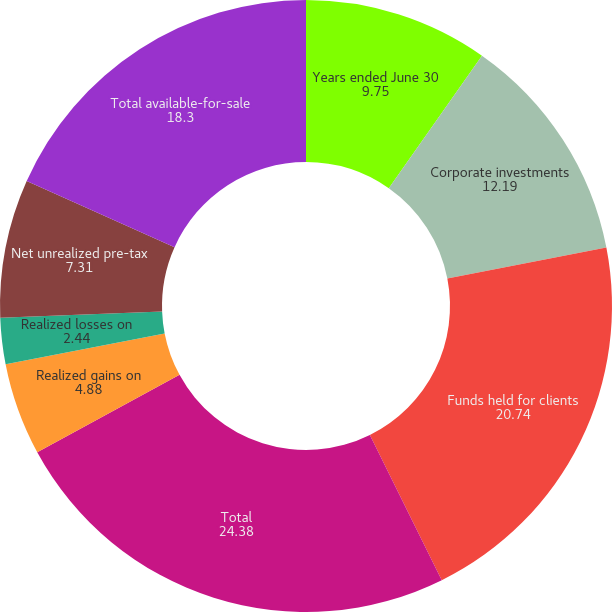Convert chart to OTSL. <chart><loc_0><loc_0><loc_500><loc_500><pie_chart><fcel>Years ended June 30<fcel>Corporate investments<fcel>Funds held for clients<fcel>Total<fcel>Realized gains on<fcel>Realized losses on<fcel>Net realized losses/(gains) on<fcel>Net unrealized pre-tax<fcel>Total available-for-sale<nl><fcel>9.75%<fcel>12.19%<fcel>20.74%<fcel>24.38%<fcel>4.88%<fcel>2.44%<fcel>0.0%<fcel>7.31%<fcel>18.3%<nl></chart> 